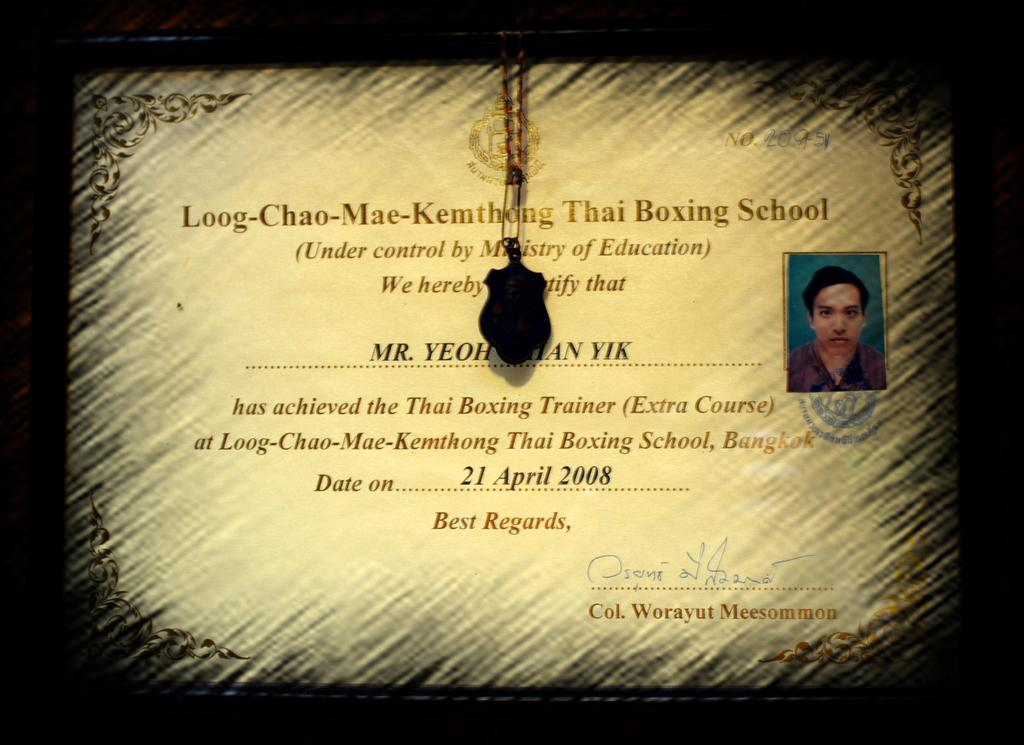What is the main object in the image? There is a frame in the image. What can be found inside the frame? The frame contains some text and a photo of a person. Are there any additional items within the frame? Yes, there is a locket in the frame. How many boats are visible in the image? There are no boats present in the image; it features a frame with text, a photo, and a locket. What type of yarn is being used to create the text in the image? There is no yarn present in the image; the text is likely printed or written on the frame. 